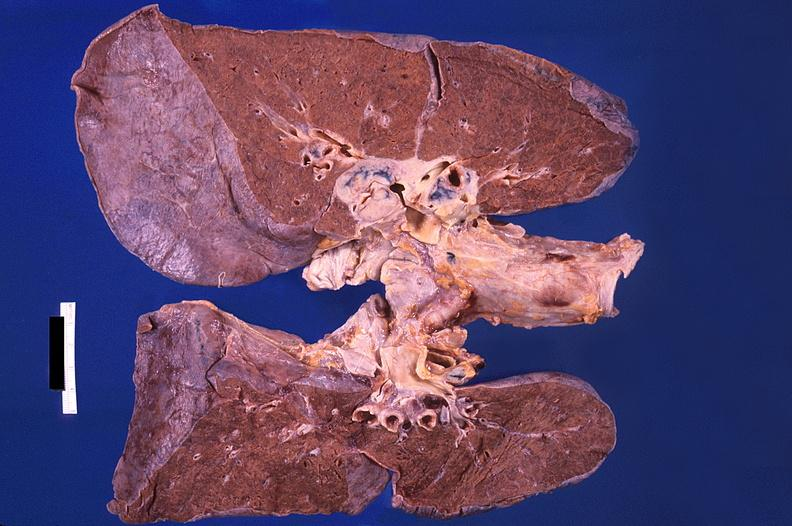does this image show hilar lymph nodes, nodular sclerosing hodgkins disease and diffuse alveolar damage with hemorrhagic pneumonia?
Answer the question using a single word or phrase. Yes 